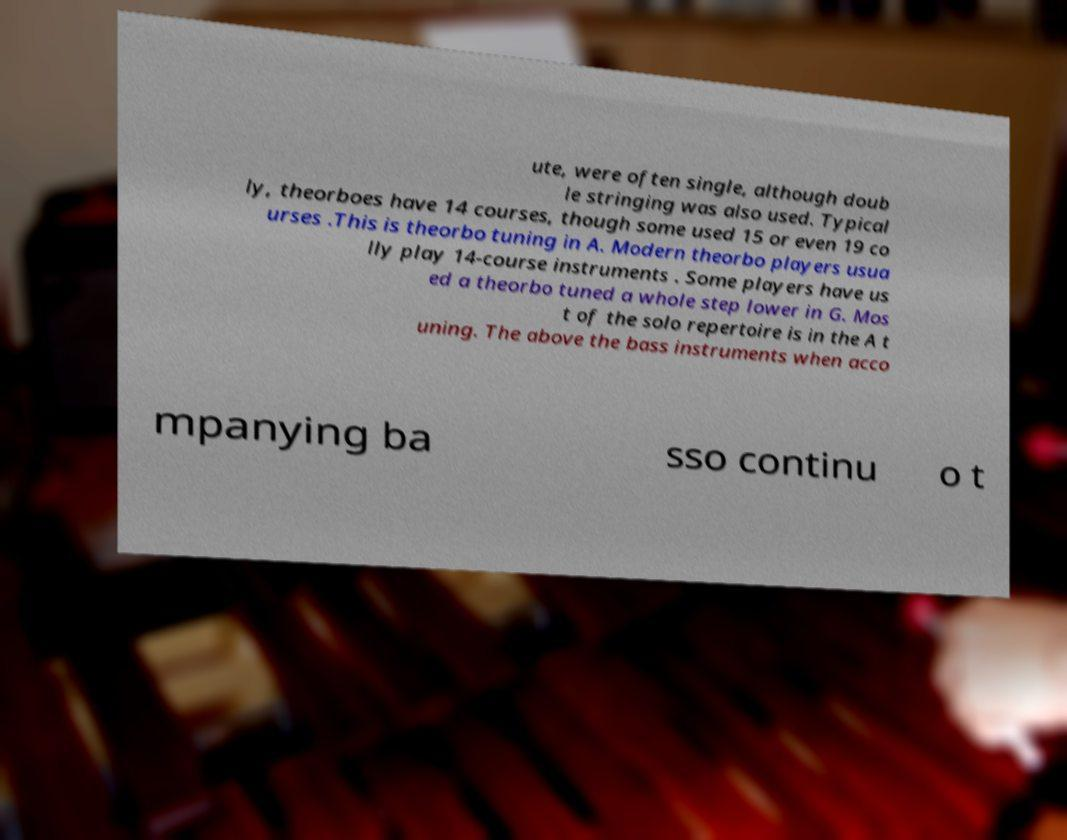Could you extract and type out the text from this image? ute, were often single, although doub le stringing was also used. Typical ly, theorboes have 14 courses, though some used 15 or even 19 co urses .This is theorbo tuning in A. Modern theorbo players usua lly play 14-course instruments . Some players have us ed a theorbo tuned a whole step lower in G. Mos t of the solo repertoire is in the A t uning. The above the bass instruments when acco mpanying ba sso continu o t 